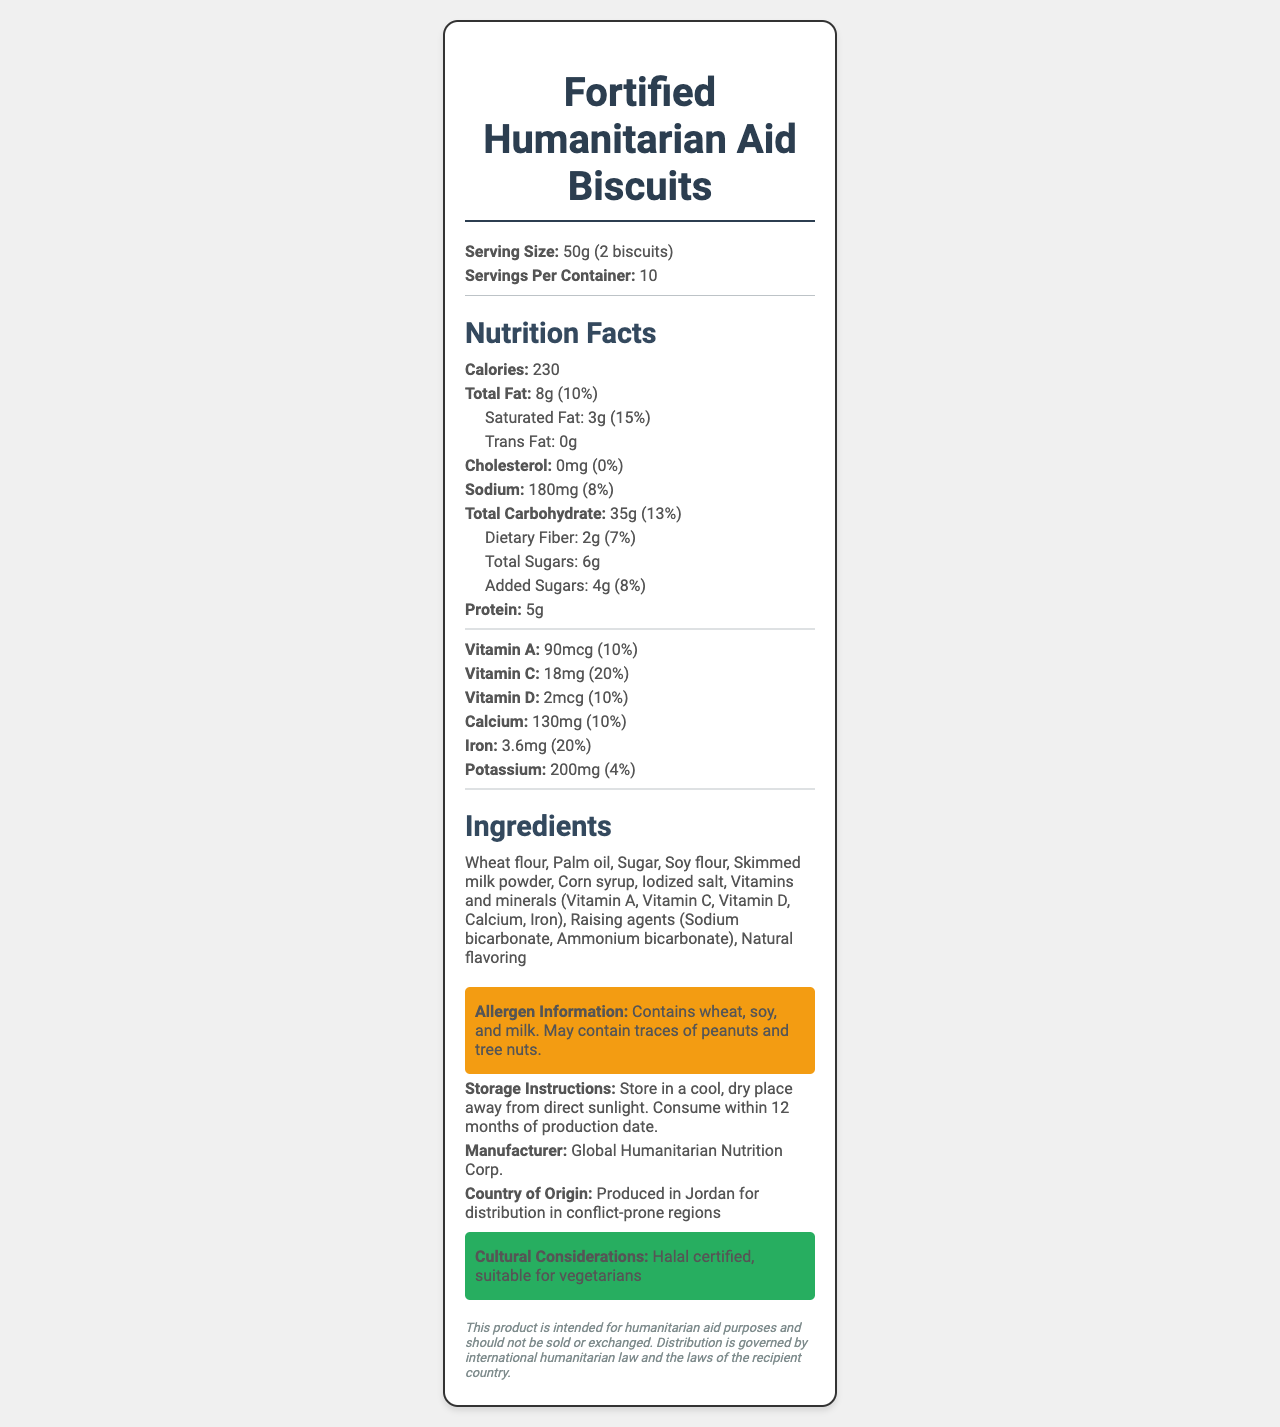what is the serving size? The serving size is explicitly mentioned in the document as "50g (2 biscuits)".
Answer: 50g (2 biscuits) how many servings are there per container? The document states that there are 10 servings per container.
Answer: 10 what is the amount of dietary fiber per serving? The document lists the dietary fiber content per serving as 2g.
Answer: 2g list three ingredients found in the biscuits The ingredients section lists "Wheat flour, Palm oil, Sugar" among other ingredients.
Answer: Wheat flour, Palm oil, Sugar what is the percentage of daily value for iron? The document specifies that the iron content per serving provides 20% of the daily value.
Answer: 20% how much saturated fat is in one serving? The amount of saturated fat per serving is listed as 3g in the document.
Answer: 3g how should the biscuits be stored? The storage instructions are clearly mentioned in the document.
Answer: Store in a cool, dry place away from direct sunlight. Consume within 12 months of production date. is the product Halal certified? The document indicates that the product is Halal certified.
Answer: Yes who is the manufacturer of the biscuits? The manufacturer is listed as Global Humanitarian Nutrition Corp.
Answer: Global Humanitarian Nutrition Corp. where are these biscuits produced? The document states that the biscuits are produced in Jordan.
Answer: Produced in Jordan which of the following allergens are present in the product? A. Eggs B. Soy C. Fish D. Shellfish The allergen information indicates that the product contains soy, with no mention of eggs, fish, or shellfish.
Answer: B. Soy Which vitamin has the highest daily value percentage per serving? i. Vitamin A ii. Vitamin C iii. Vitamin D iv. Calcium Vitamin C has the highest daily value percentage per serving at 20%, higher than Vitamin A (10%), Vitamin D (10%), and Calcium (10%).
Answer: ii. Vitamin C does the product contain any cholesterol? The document mentions that the cholesterol content is 0mg, which translates to 0% of the daily value.
Answer: No can I determine the exact production date of the biscuits? The document does not provide the exact production date of the biscuits.
Answer: Not enough information summarize the main idea of the document The document aims to present comprehensive nutritional facts and related details about the Fortified Humanitarian Aid Biscuits, specifying they are produced for relief efforts in conflict-prone regions.
Answer: The document provides detailed nutritional information for Fortified Humanitarian Aid Biscuits, including serving size, calorie content, and nutrient amounts per serving. It lists ingredients, allergen information, storage instructions, manufacturer details, and indicates that the product is Halal certified and suitable for vegetarians. The biscuits are designed for humanitarian aid and produced in Jordan. 